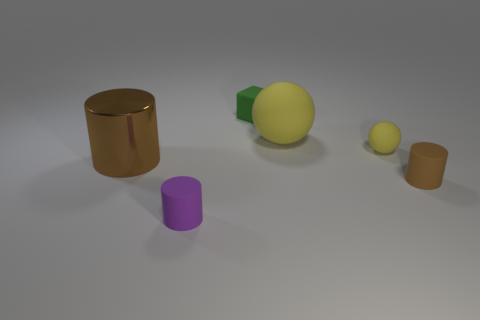Are there any other things that are the same shape as the small green rubber thing?
Provide a succinct answer. No. How many small objects are green objects or rubber spheres?
Give a very brief answer. 2. There is a small ball that is the same color as the big rubber ball; what is it made of?
Offer a very short reply. Rubber. Is there a tiny cube that has the same material as the large brown object?
Offer a very short reply. No. There is a brown cylinder on the left side of the green block; is its size the same as the tiny ball?
Ensure brevity in your answer.  No. There is a small cylinder that is to the left of the brown cylinder in front of the metal object; is there a cube in front of it?
Provide a succinct answer. No. How many metallic objects are brown things or yellow objects?
Offer a very short reply. 1. What number of other objects are the same shape as the tiny purple rubber object?
Keep it short and to the point. 2. Are there more small gray spheres than tiny yellow rubber spheres?
Make the answer very short. No. There is a cylinder to the right of the small cylinder that is on the left side of the green cube that is behind the big yellow rubber sphere; what is its size?
Make the answer very short. Small. 